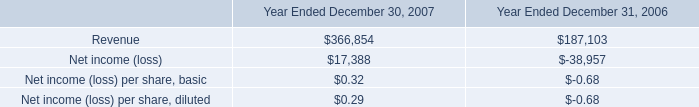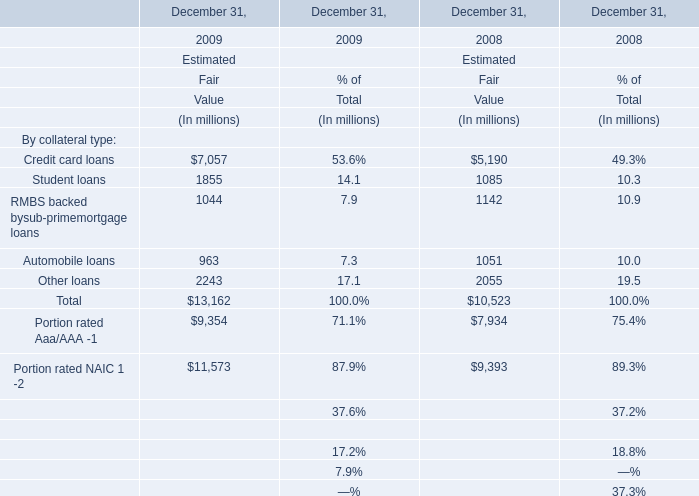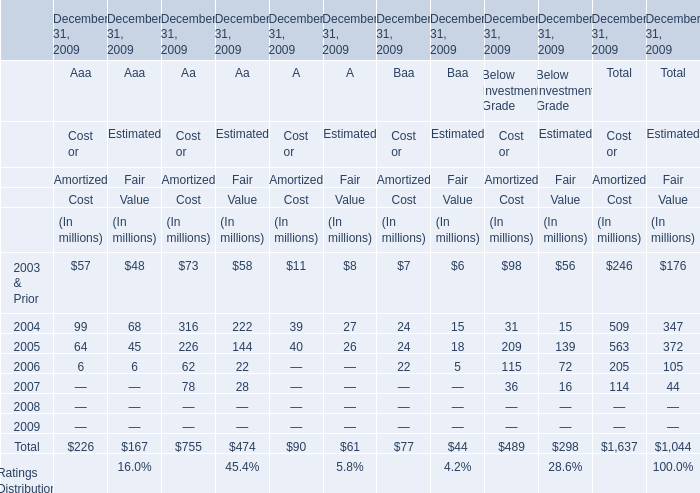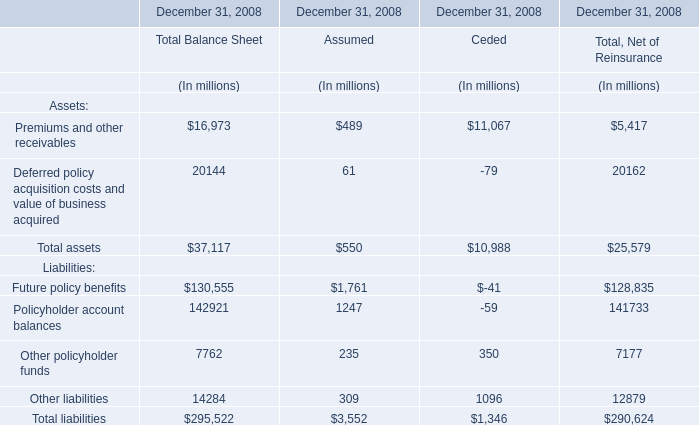In which year is the Estimated Fair Value for Other loans greater than 2200 million? 
Answer: 2009. 